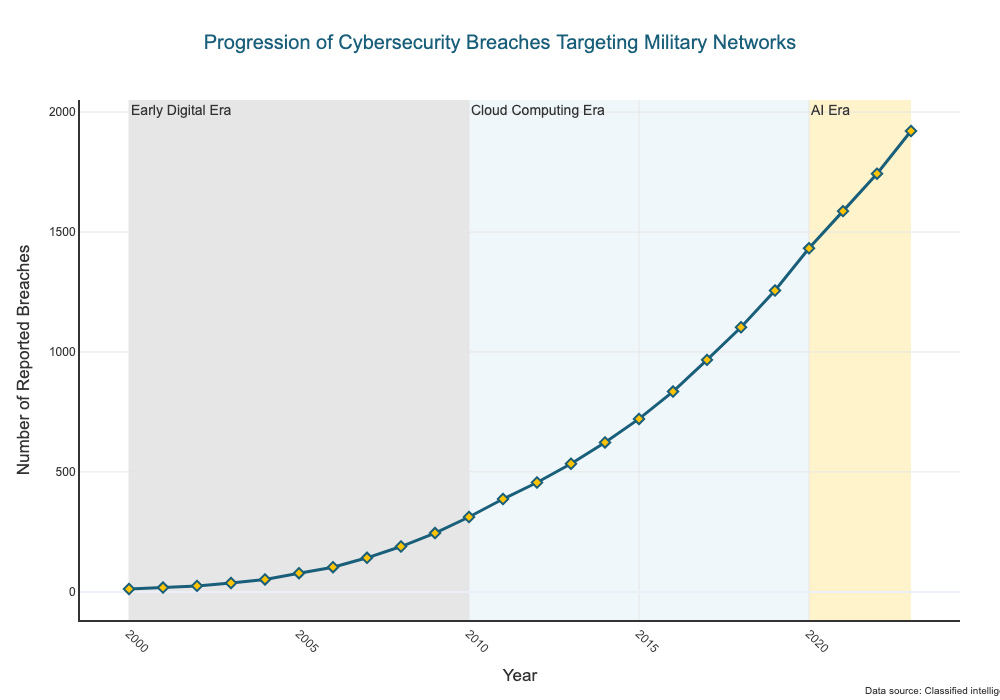How many reported breaches were there in 2015 and 2017 combined? The figure shows that the number of reported breaches in 2015 is 721 and in 2017 is 967. Adding these together gives 721 + 967 = 1688
Answer: 1688 How much has the number of reported breaches increased from 2000 to 2023? The figure shows that the number of reported breaches in 2000 is 12 and in 2023 is 1921. The increase is 1921 - 12 = 1909
Answer: 1909 During which period did the number of reported breaches grow the fastest? Observing the line's steepness in the different shaded sections, the slope is steepest from 2010 to 2020 (Cloud Computing Era), indicating the fastest growth during this period
Answer: Cloud Computing Era By how many reported breaches did the number of breaches increase between the Early Digital Era and AI Era? The Early Digital Era is from 2000 to 2010, and the AI Era is from 2020 to 2023. The number of reported breaches in 2010 is 312 and in 2023 is 1921. The increase is 1921 - 312 = 1609
Answer: 1609 How does the number of reported breaches in 2006 compare to that in 2012? The figure shows 103 reported breaches in 2006 and 456 in 2012. Therefore, the number in 2006 is less than that in 2012
Answer: Less What is the difference in the number of reported breaches between 2001 and 2021? The number of reported breaches in 2001 is 18, and in 2021 it is 1587. The difference is 1587 - 18 = 1569
Answer: 1569 Which year marked the first instance where the number of reported breaches surpassed 1000? The number of reported breaches first surpassed 1000 in 2018, with 1103 reported breaches
Answer: 2018 What visual clues indicate the three different periods on the graph? Each period is marked by shaded areas in different colors: Early Digital Era (gray), Cloud Computing Era (light blue), and AI Era (yellow) with annotations specifying each era's time frame
Answer: Shaded areas and annotations In which year did the number of reported breaches cross the threshold of 500? The figure shows that the number of reported breaches in 2013 was 534, which is the first instance surpassing 500
Answer: 2013 